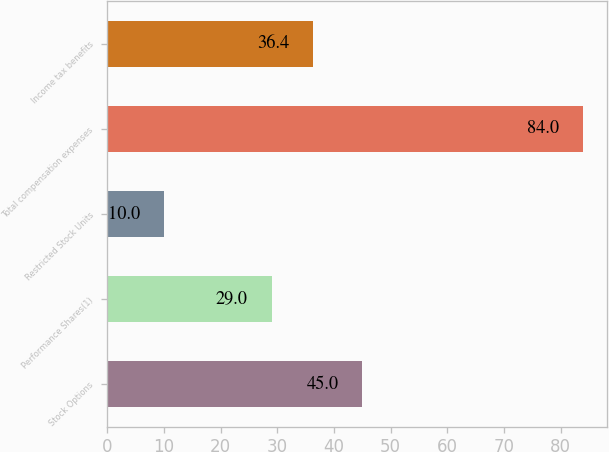Convert chart. <chart><loc_0><loc_0><loc_500><loc_500><bar_chart><fcel>Stock Options<fcel>Performance Shares(1)<fcel>Restricted Stock Units<fcel>Total compensation expenses<fcel>Income tax benefits<nl><fcel>45<fcel>29<fcel>10<fcel>84<fcel>36.4<nl></chart> 